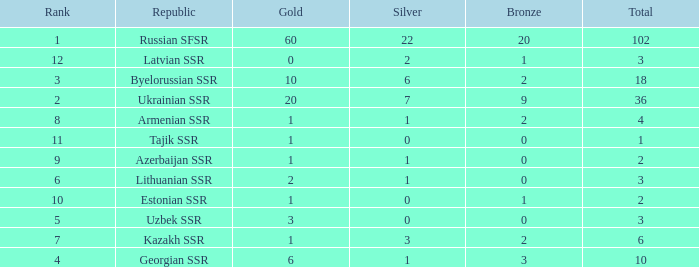What is the total number of bronzes associated with 1 silver, ranks under 6 and under 6 golds? None. 